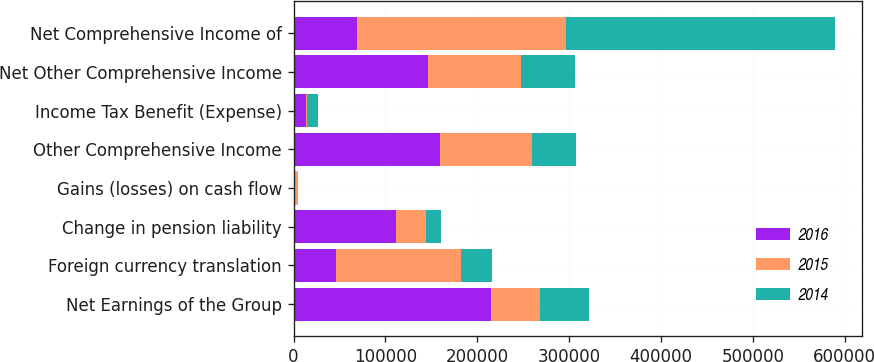Convert chart. <chart><loc_0><loc_0><loc_500><loc_500><stacked_bar_chart><ecel><fcel>Net Earnings of the Group<fcel>Foreign currency translation<fcel>Change in pension liability<fcel>Gains (losses) on cash flow<fcel>Other Comprehensive Income<fcel>Income Tax Benefit (Expense)<fcel>Net Other Comprehensive Income<fcel>Net Comprehensive Income of<nl><fcel>2016<fcel>214515<fcel>46515<fcel>111488<fcel>1403<fcel>159406<fcel>13576<fcel>145830<fcel>68685<nl><fcel>2015<fcel>53509.5<fcel>136168<fcel>33208<fcel>2949<fcel>100011<fcel>1204<fcel>101215<fcel>227667<nl><fcel>2014<fcel>53509.5<fcel>33316<fcel>15303<fcel>1022<fcel>47597<fcel>11825<fcel>59422<fcel>292690<nl></chart> 